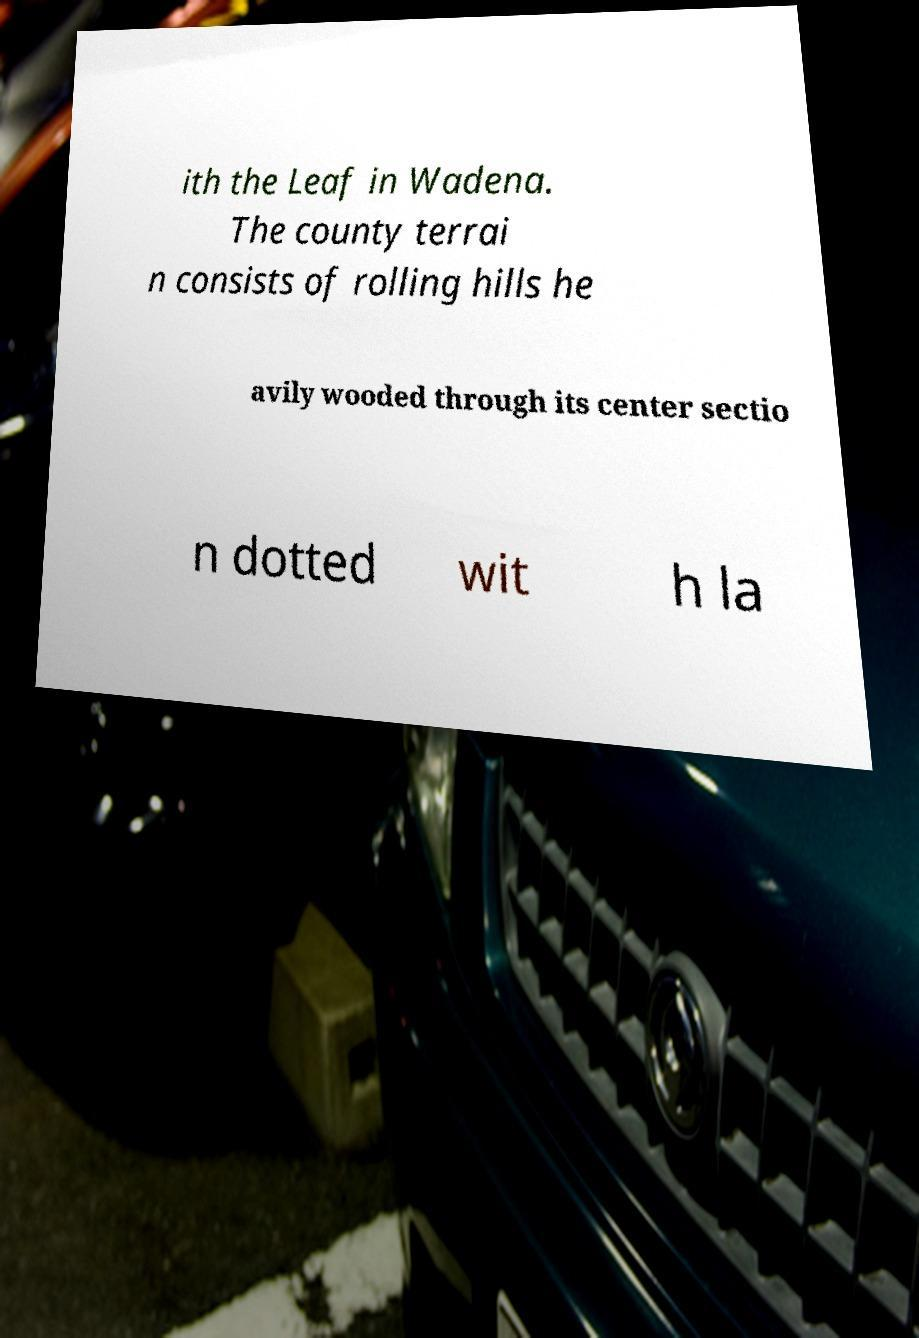Could you assist in decoding the text presented in this image and type it out clearly? ith the Leaf in Wadena. The county terrai n consists of rolling hills he avily wooded through its center sectio n dotted wit h la 